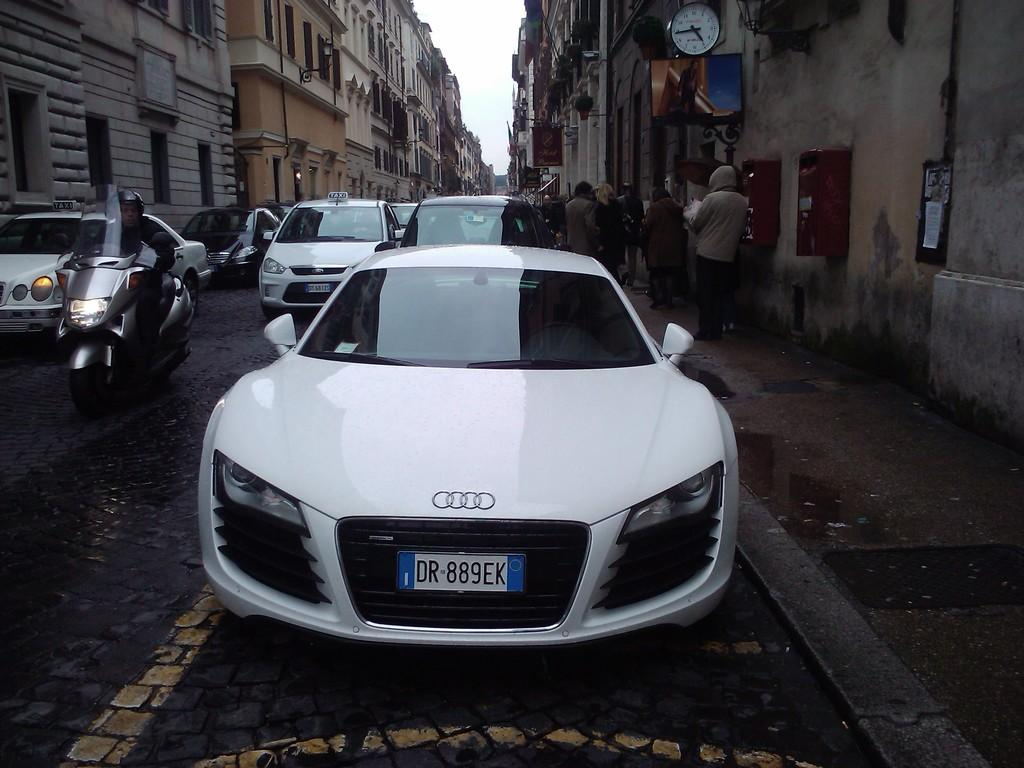What color are the cars in the image? The cars in the image are white. What else can be seen in the image besides the cars? There is a group of people, a motorcycle, buildings, windows, a clock, and the sky visible in the image. Can you describe the group of people in the image? The group of people in the image is not specified, but their presence is noted. What architectural feature is present in the buildings in the image? The presence of windows in the image suggests that the buildings have windows as an architectural feature. What time-telling device is present in the image? There is a clock in the image. What is visible at the top of the image? The sky is visible at the top of the image. What type of straw is being used to clean the cat's ears in the image? There is no cat or straw present in the image; it features white color cars, a group of people, a motorcycle, buildings, windows, a clock, and the sky. 